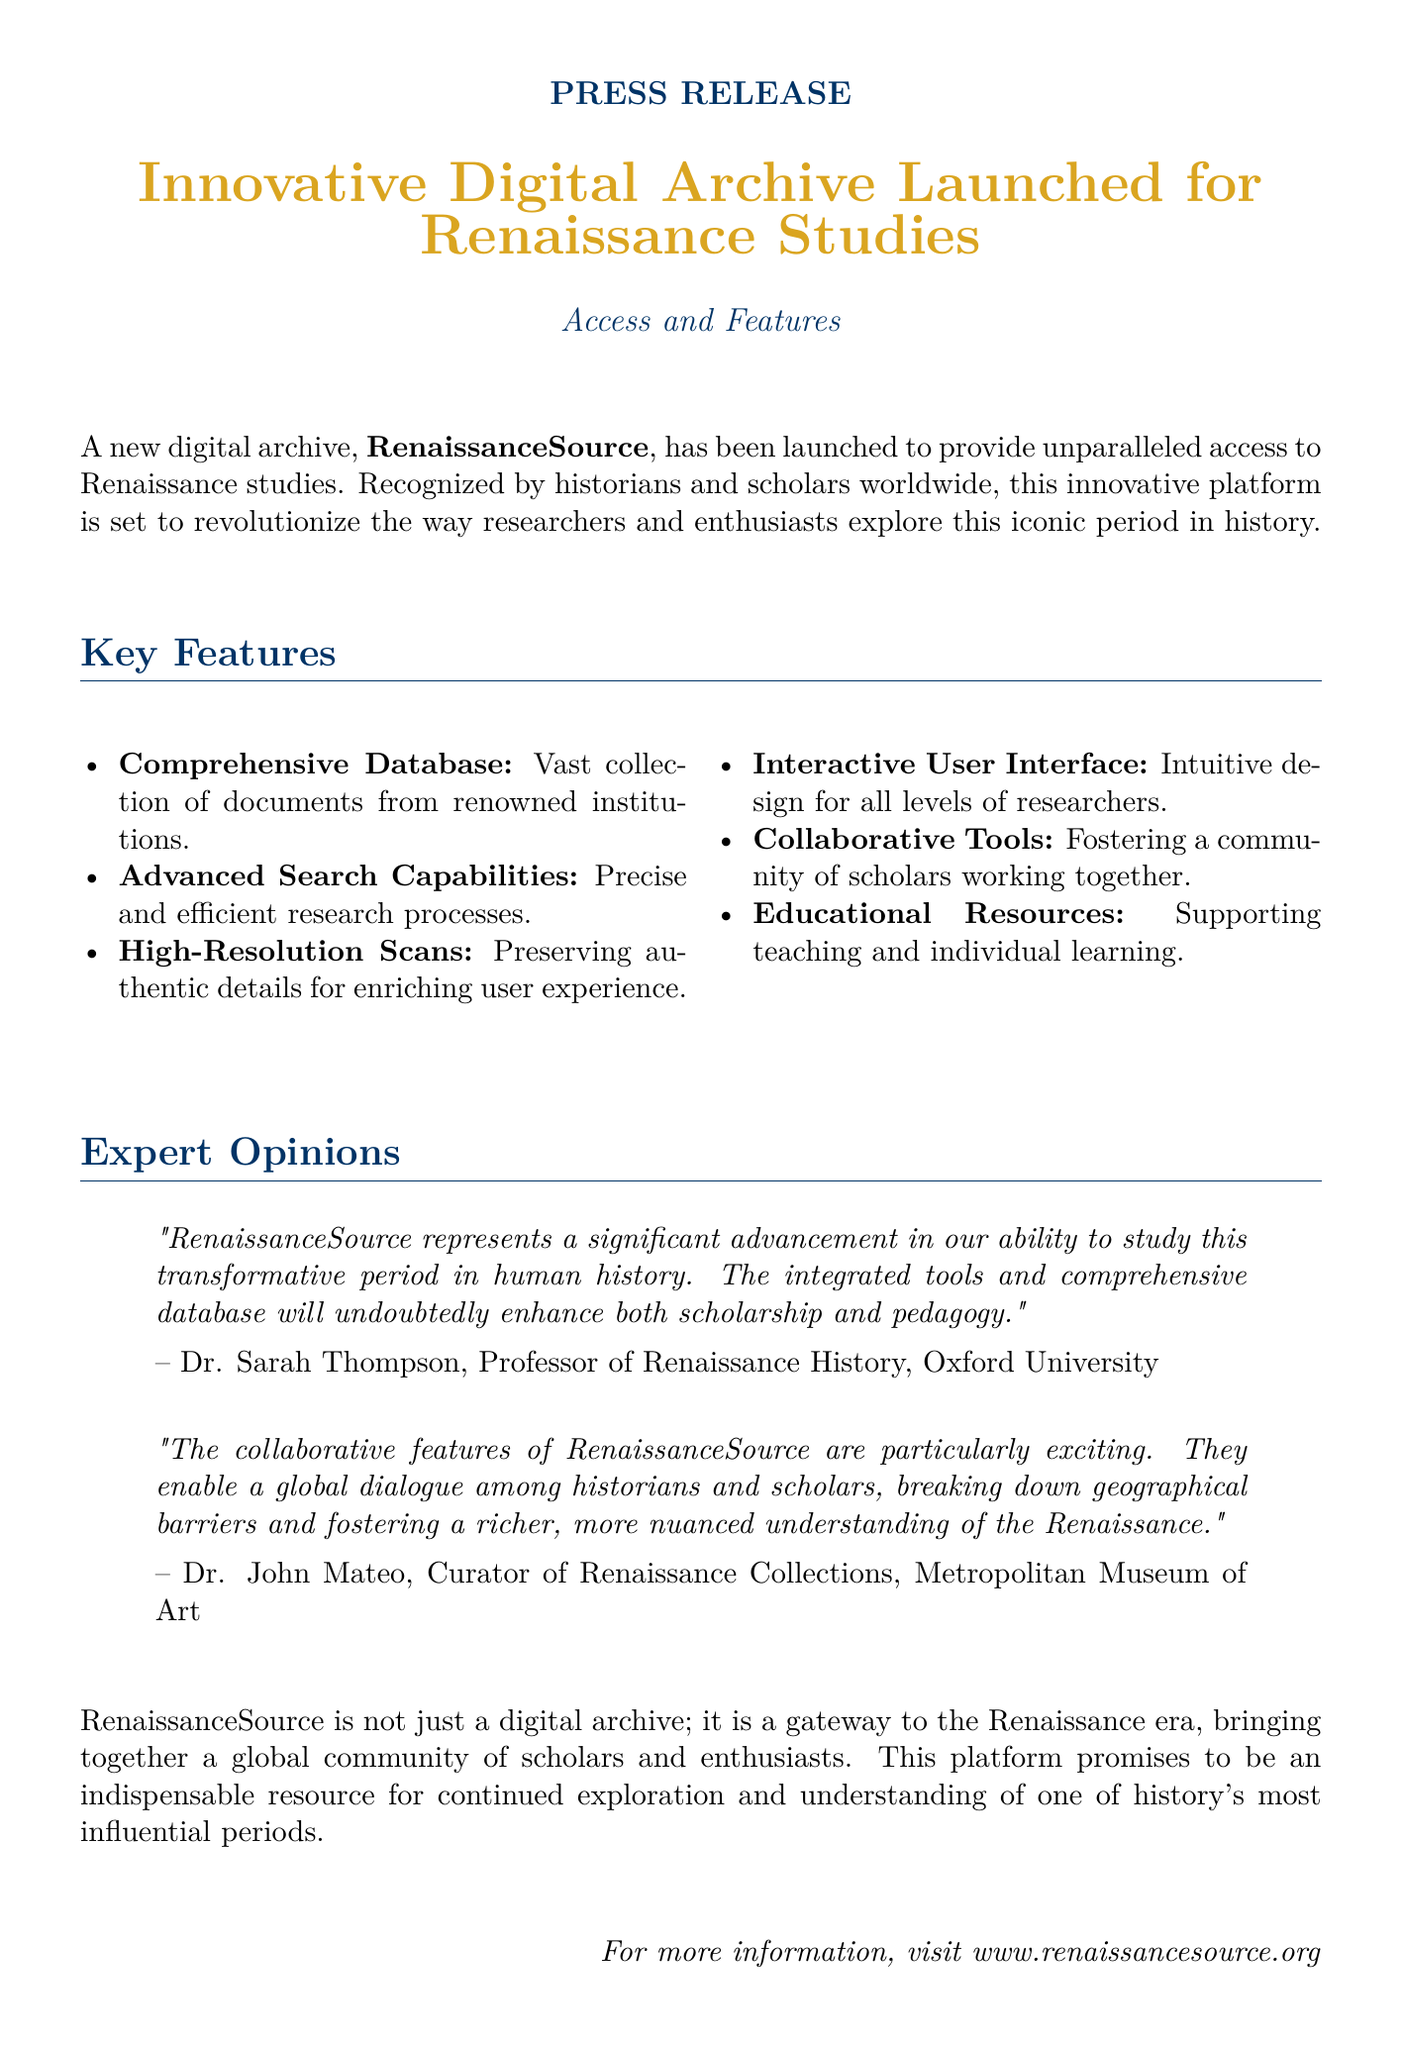What is the name of the newly launched digital archive? The document states that the new digital archive is called "RenaissanceSource."
Answer: RenaissanceSource Who described RenaissanceSource as a significant advancement for studying the Renaissance? According to the document, Dr. Sarah Thompson, Professor of Renaissance History at Oxford University, described it this way.
Answer: Dr. Sarah Thompson What are the two types of resources mentioned that RenaissanceSource supports? The document mentions that RenaissanceSource supports teaching and individual learning.
Answer: Teaching and individual learning How many key features of RenaissanceSource are listed? The document lists six key features of RenaissanceSource.
Answer: Six What is one interactive feature of RenaissanceSource? The document states that there is an "Interactive User Interface" that is intuitive for all levels of researchers.
Answer: Interactive User Interface What type of documents does RenaissanceSource provide? The document refers to a "Vast collection of documents from renowned institutions."
Answer: Vast collection of documents What quote emphasizes the collaborative nature of RenaissanceSource? The document includes a quote by Dr. John Mateo about the exciting collaborative features of RenaissanceSource.
Answer: "The collaborative features of RenaissanceSource are particularly exciting." What is the purpose of the digital archive according to the document? The document describes RenaissanceSource as a "gateway to the Renaissance era."
Answer: Gateway to the Renaissance era 